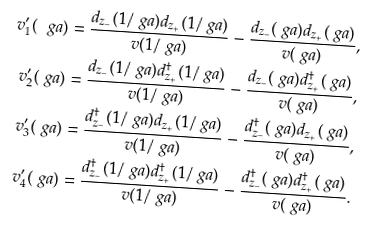Convert formula to latex. <formula><loc_0><loc_0><loc_500><loc_500>v _ { 1 } ^ { \prime } ( \ g a ) & = \frac { d _ { z _ { - } } ( 1 / \ g a ) d _ { z _ { + } } ( 1 / \ g a ) } { v ( 1 / \ g a ) } - \frac { d _ { z _ { - } } ( \ g a ) d _ { z _ { + } } ( \ g a ) } { v ( \ g a ) } , \\ v _ { 2 } ^ { \prime } ( \ g a ) & = \frac { d _ { z _ { - } } ( 1 / \ g a ) d _ { z _ { + } } ^ { \dagger } ( 1 / \ g a ) } { v ( 1 / \ g a ) } - \frac { d _ { z _ { - } } ( \ g a ) d _ { z _ { + } } ^ { \dagger } ( \ g a ) } { v ( \ g a ) } , \\ v _ { 3 } ^ { \prime } ( \ g a ) & = \frac { d _ { z _ { - } } ^ { \dagger } ( 1 / \ g a ) d _ { z _ { + } } ( 1 / \ g a ) } { v ( 1 / \ g a ) } - \frac { d _ { z _ { - } } ^ { \dagger } ( \ g a ) d _ { z _ { + } } ( \ g a ) } { v ( \ g a ) } , \\ v _ { 4 } ^ { \prime } ( \ g a ) & = \frac { d _ { z _ { - } } ^ { \dagger } ( 1 / \ g a ) d _ { z _ { + } } ^ { \dagger } ( 1 / \ g a ) } { v ( 1 / \ g a ) } - \frac { d _ { z _ { - } } ^ { \dagger } ( \ g a ) d _ { z _ { + } } ^ { \dagger } ( \ g a ) } { v ( \ g a ) } .</formula> 